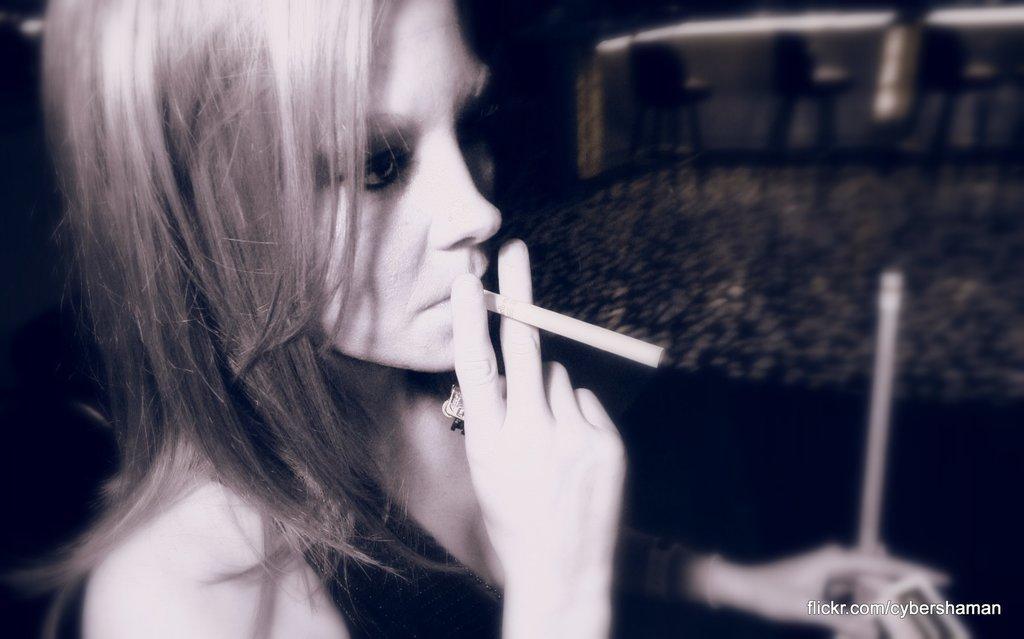Please provide a concise description of this image. In the image there is a woman in the foreground she is holding a cigar with her fingers, the background of the woman is blur. 